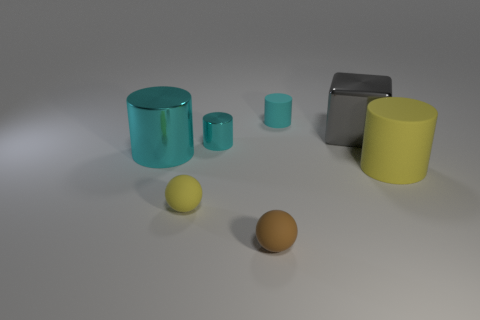Is there any other thing that has the same shape as the gray metal object?
Ensure brevity in your answer.  No. Are there any big cyan cylinders to the left of the large yellow cylinder?
Offer a terse response. Yes. The brown thing has what size?
Provide a short and direct response. Small. The yellow matte thing that is the same shape as the small cyan rubber object is what size?
Ensure brevity in your answer.  Large. What number of tiny metal objects are in front of the tiny cylinder on the right side of the tiny brown matte ball?
Offer a very short reply. 1. Is the material of the tiny cyan cylinder behind the big gray cube the same as the yellow thing to the left of the yellow matte cylinder?
Provide a short and direct response. Yes. What number of yellow matte things have the same shape as the small brown thing?
Give a very brief answer. 1. What number of shiny things are the same color as the large metal cylinder?
Offer a very short reply. 1. Does the tiny cyan metal thing to the left of the small cyan rubber cylinder have the same shape as the large metallic object that is to the left of the tiny brown object?
Provide a succinct answer. Yes. What number of large objects are on the right side of the cyan cylinder behind the gray block behind the small yellow sphere?
Your answer should be very brief. 2. 